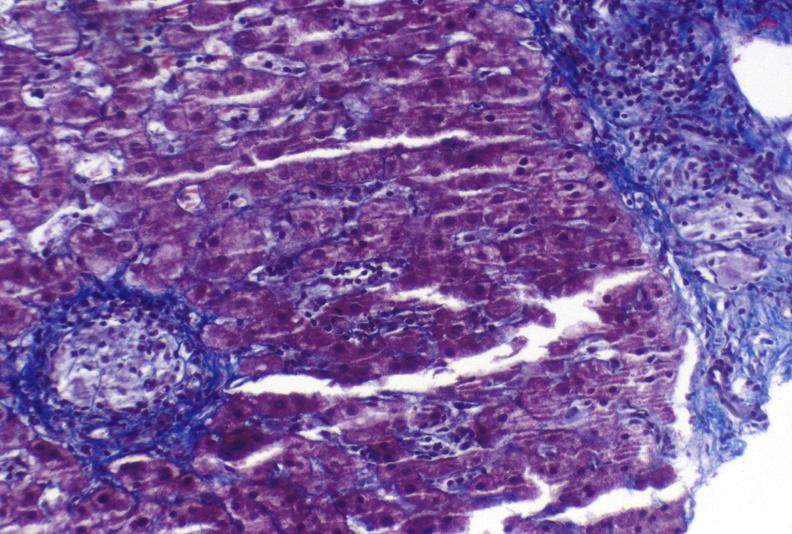does this image show sarcoid?
Answer the question using a single word or phrase. Yes 